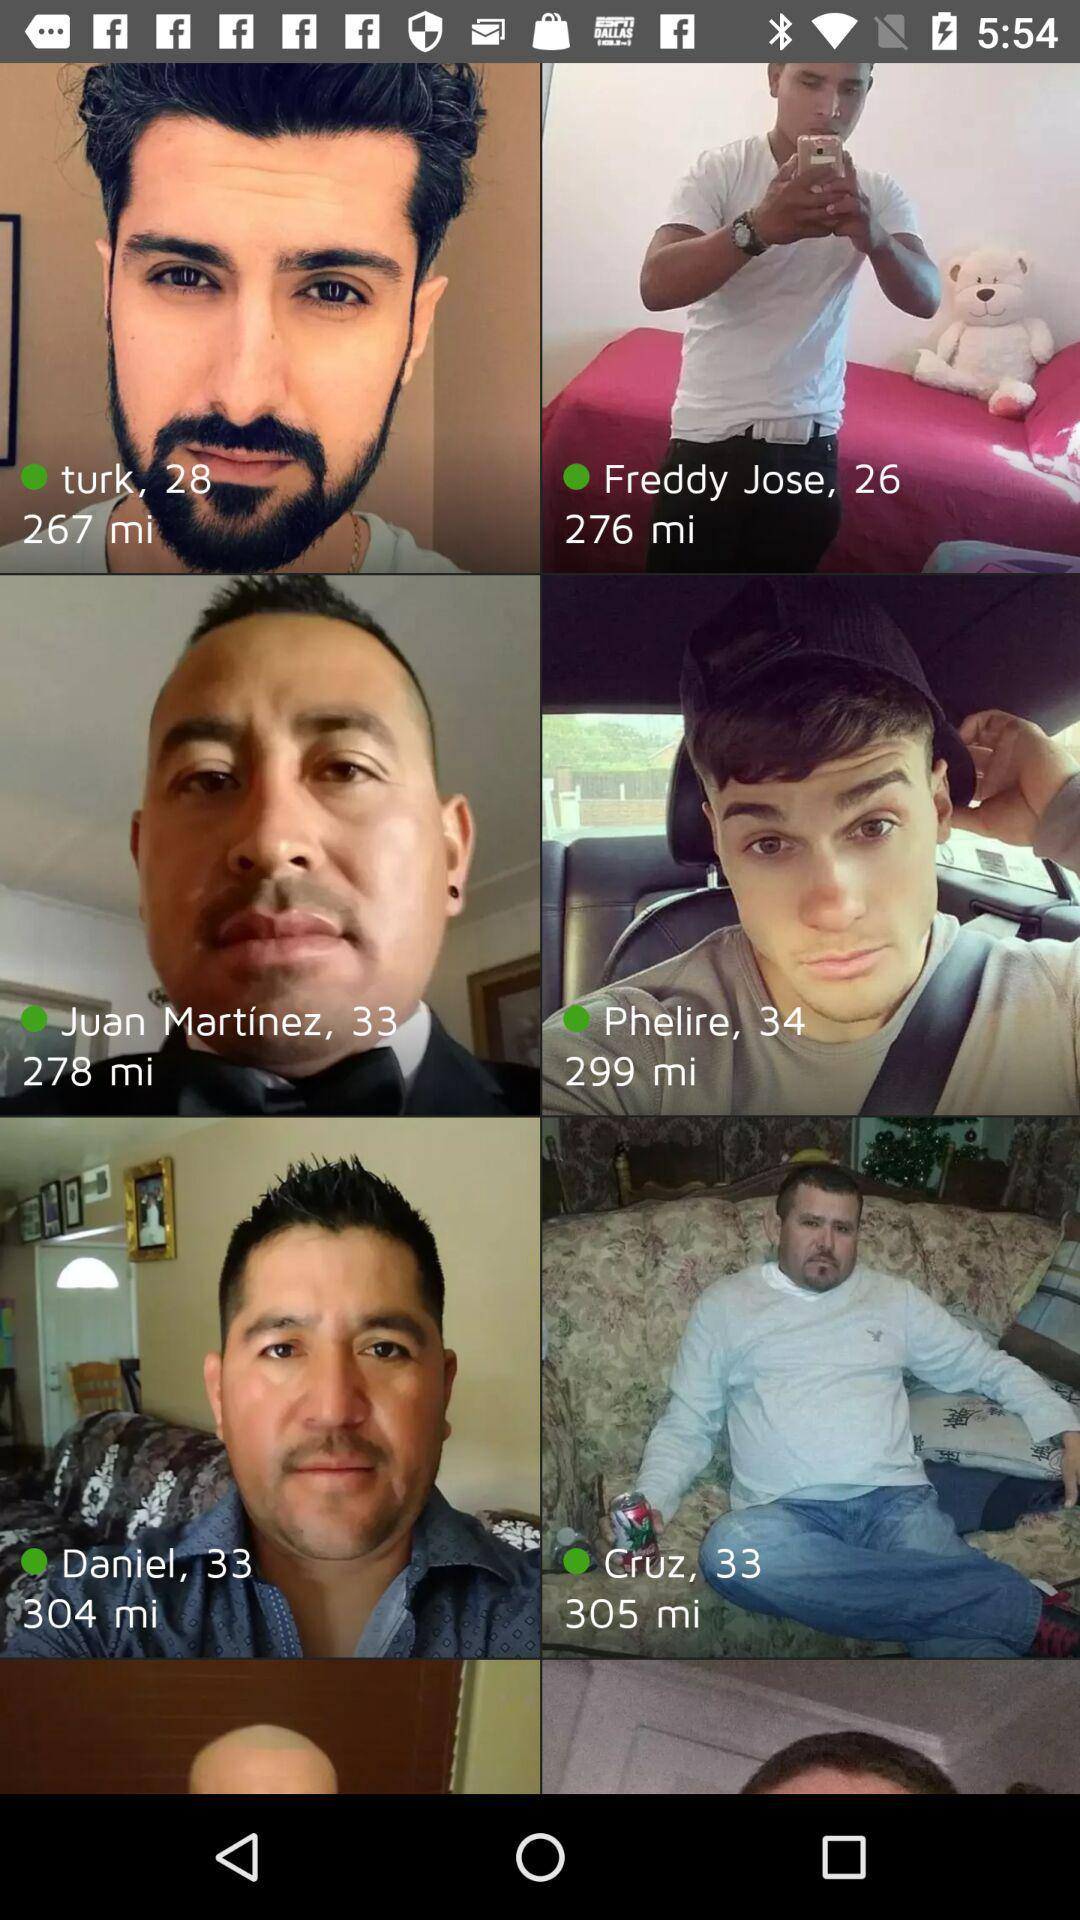How far is the Turk from my location? Turk is 267 miles away from my location. 